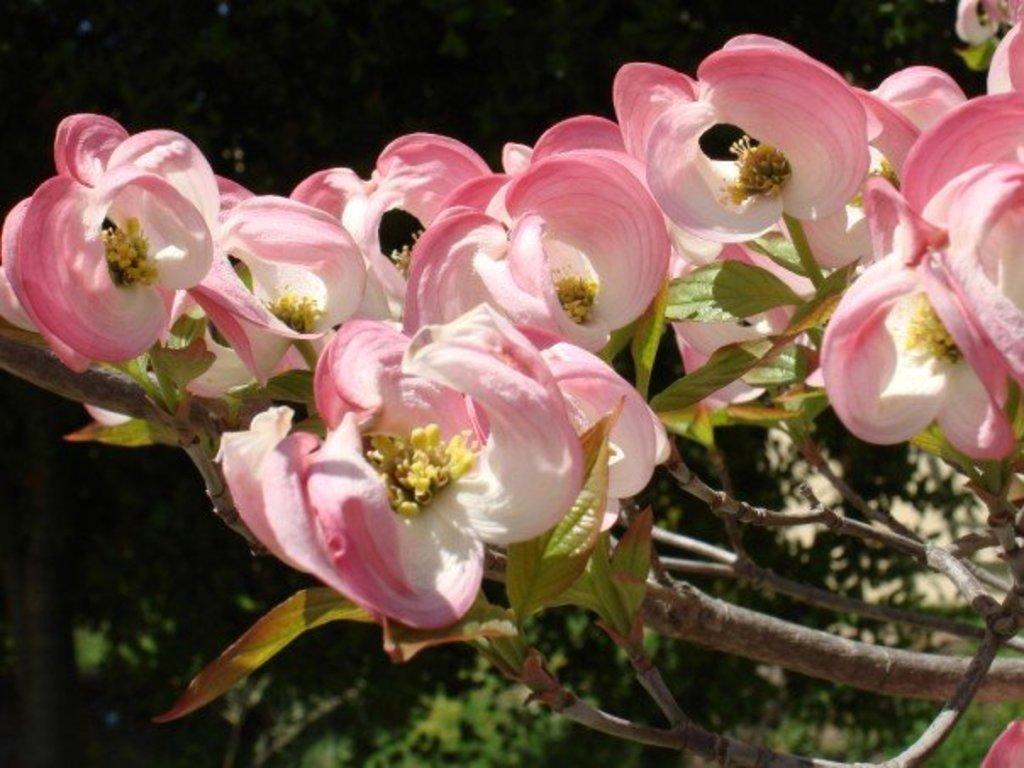How would you summarize this image in a sentence or two? Here we can see flowers. There is a dark background and we can see trees. 